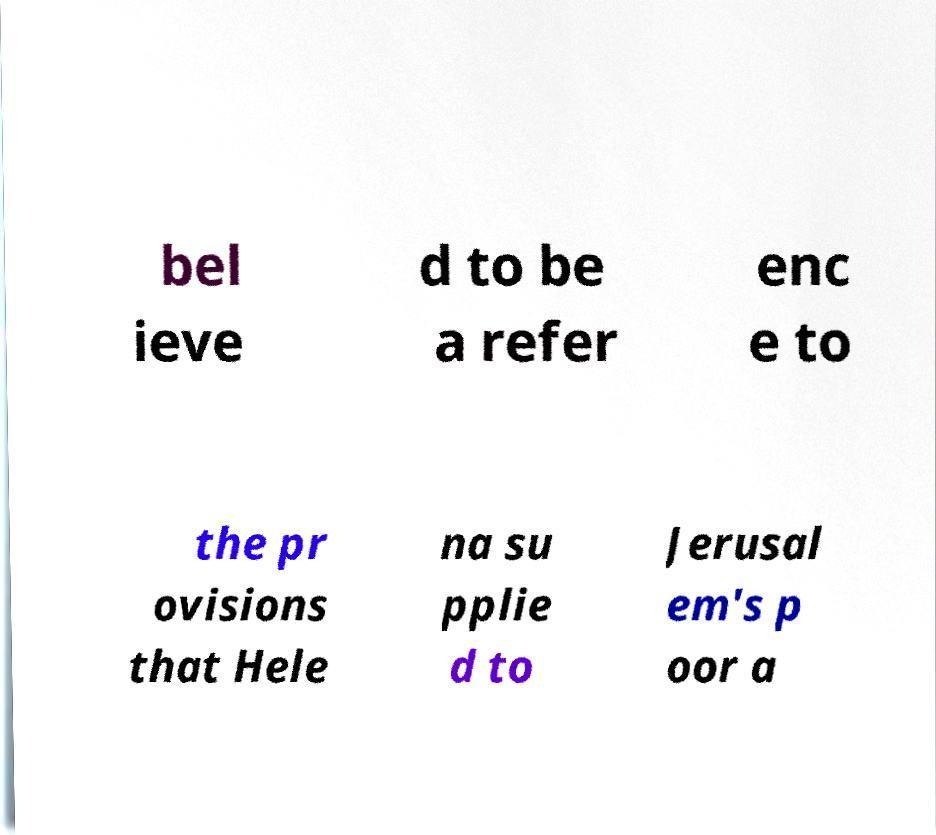Please read and relay the text visible in this image. What does it say? bel ieve d to be a refer enc e to the pr ovisions that Hele na su pplie d to Jerusal em's p oor a 